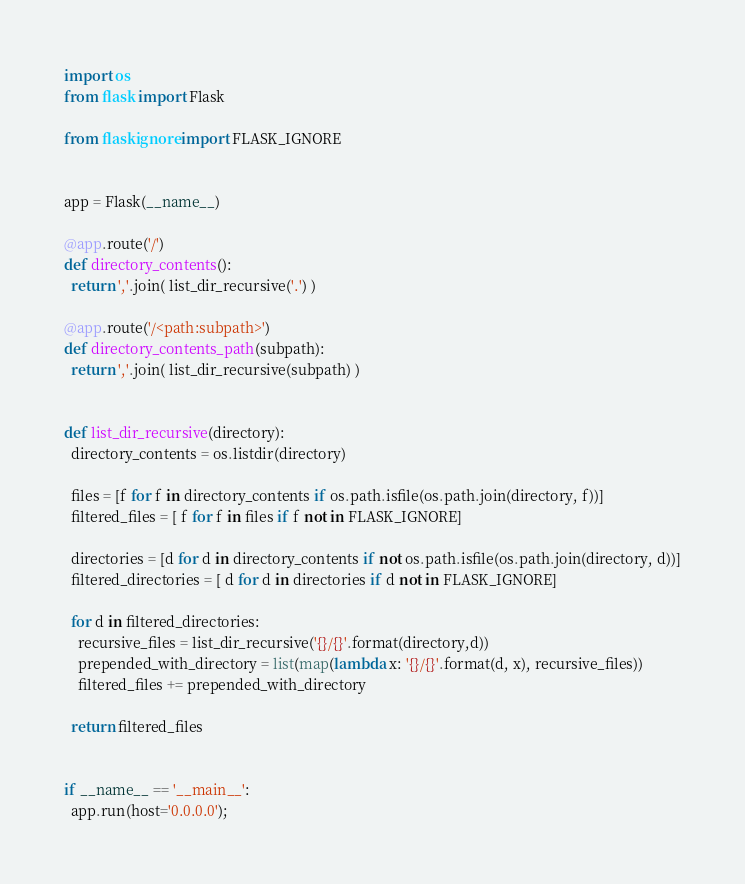<code> <loc_0><loc_0><loc_500><loc_500><_Python_>import os
from flask import Flask

from flaskignore import FLASK_IGNORE


app = Flask(__name__)

@app.route('/')
def directory_contents():
  return ','.join( list_dir_recursive('.') )

@app.route('/<path:subpath>')
def directory_contents_path(subpath):
  return ','.join( list_dir_recursive(subpath) )


def list_dir_recursive(directory):
  directory_contents = os.listdir(directory)

  files = [f for f in directory_contents if os.path.isfile(os.path.join(directory, f))]
  filtered_files = [ f for f in files if f not in FLASK_IGNORE]

  directories = [d for d in directory_contents if not os.path.isfile(os.path.join(directory, d))]
  filtered_directories = [ d for d in directories if d not in FLASK_IGNORE]

  for d in filtered_directories:
    recursive_files = list_dir_recursive('{}/{}'.format(directory,d))
    prepended_with_directory = list(map(lambda x: '{}/{}'.format(d, x), recursive_files))
    filtered_files += prepended_with_directory

  return filtered_files


if __name__ == '__main__':
  app.run(host='0.0.0.0');
</code> 